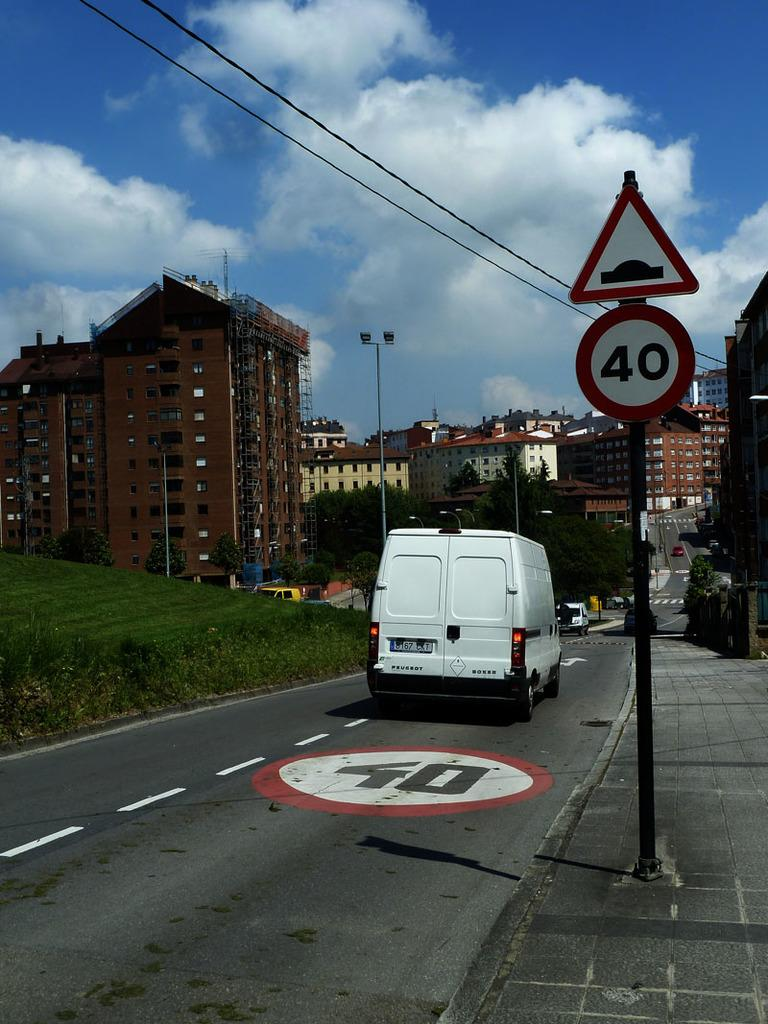<image>
Share a concise interpretation of the image provided. A sign has the number 40 on it and is near a spot on the road that also has the number 40. 